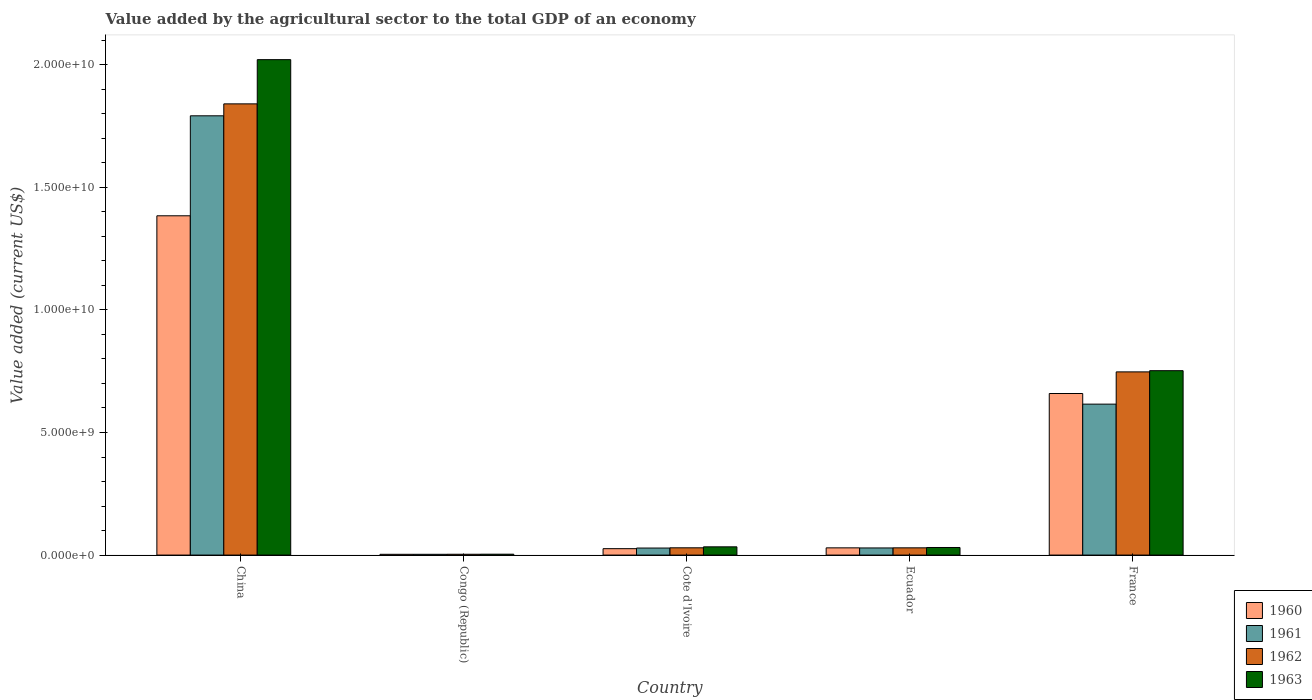How many bars are there on the 2nd tick from the left?
Provide a short and direct response. 4. What is the label of the 1st group of bars from the left?
Keep it short and to the point. China. In how many cases, is the number of bars for a given country not equal to the number of legend labels?
Give a very brief answer. 0. What is the value added by the agricultural sector to the total GDP in 1962 in Congo (Republic)?
Offer a terse response. 3.30e+07. Across all countries, what is the maximum value added by the agricultural sector to the total GDP in 1961?
Keep it short and to the point. 1.79e+1. Across all countries, what is the minimum value added by the agricultural sector to the total GDP in 1962?
Your answer should be compact. 3.30e+07. In which country was the value added by the agricultural sector to the total GDP in 1961 minimum?
Make the answer very short. Congo (Republic). What is the total value added by the agricultural sector to the total GDP in 1960 in the graph?
Offer a very short reply. 2.10e+1. What is the difference between the value added by the agricultural sector to the total GDP in 1960 in Ecuador and that in France?
Provide a succinct answer. -6.30e+09. What is the difference between the value added by the agricultural sector to the total GDP in 1963 in Ecuador and the value added by the agricultural sector to the total GDP in 1962 in France?
Your answer should be compact. -7.16e+09. What is the average value added by the agricultural sector to the total GDP in 1962 per country?
Your response must be concise. 5.30e+09. What is the difference between the value added by the agricultural sector to the total GDP of/in 1960 and value added by the agricultural sector to the total GDP of/in 1961 in France?
Make the answer very short. 4.33e+08. What is the ratio of the value added by the agricultural sector to the total GDP in 1962 in China to that in Cote d'Ivoire?
Make the answer very short. 62.14. Is the difference between the value added by the agricultural sector to the total GDP in 1960 in China and Congo (Republic) greater than the difference between the value added by the agricultural sector to the total GDP in 1961 in China and Congo (Republic)?
Your answer should be compact. No. What is the difference between the highest and the second highest value added by the agricultural sector to the total GDP in 1962?
Ensure brevity in your answer.  -1.09e+1. What is the difference between the highest and the lowest value added by the agricultural sector to the total GDP in 1962?
Your response must be concise. 1.84e+1. In how many countries, is the value added by the agricultural sector to the total GDP in 1961 greater than the average value added by the agricultural sector to the total GDP in 1961 taken over all countries?
Provide a succinct answer. 2. Is it the case that in every country, the sum of the value added by the agricultural sector to the total GDP in 1960 and value added by the agricultural sector to the total GDP in 1963 is greater than the sum of value added by the agricultural sector to the total GDP in 1961 and value added by the agricultural sector to the total GDP in 1962?
Keep it short and to the point. No. Is it the case that in every country, the sum of the value added by the agricultural sector to the total GDP in 1962 and value added by the agricultural sector to the total GDP in 1963 is greater than the value added by the agricultural sector to the total GDP in 1961?
Keep it short and to the point. Yes. How many countries are there in the graph?
Your answer should be compact. 5. Are the values on the major ticks of Y-axis written in scientific E-notation?
Make the answer very short. Yes. Does the graph contain any zero values?
Your answer should be compact. No. How many legend labels are there?
Your response must be concise. 4. How are the legend labels stacked?
Your answer should be compact. Vertical. What is the title of the graph?
Ensure brevity in your answer.  Value added by the agricultural sector to the total GDP of an economy. What is the label or title of the Y-axis?
Offer a very short reply. Value added (current US$). What is the Value added (current US$) of 1960 in China?
Make the answer very short. 1.38e+1. What is the Value added (current US$) in 1961 in China?
Give a very brief answer. 1.79e+1. What is the Value added (current US$) in 1962 in China?
Offer a terse response. 1.84e+1. What is the Value added (current US$) of 1963 in China?
Offer a very short reply. 2.02e+1. What is the Value added (current US$) of 1960 in Congo (Republic)?
Your answer should be compact. 3.11e+07. What is the Value added (current US$) of 1961 in Congo (Republic)?
Your response must be concise. 3.11e+07. What is the Value added (current US$) of 1962 in Congo (Republic)?
Provide a short and direct response. 3.30e+07. What is the Value added (current US$) of 1963 in Congo (Republic)?
Your response must be concise. 3.61e+07. What is the Value added (current US$) of 1960 in Cote d'Ivoire?
Give a very brief answer. 2.62e+08. What is the Value added (current US$) in 1961 in Cote d'Ivoire?
Keep it short and to the point. 2.87e+08. What is the Value added (current US$) in 1962 in Cote d'Ivoire?
Your response must be concise. 2.96e+08. What is the Value added (current US$) in 1963 in Cote d'Ivoire?
Provide a short and direct response. 3.36e+08. What is the Value added (current US$) in 1960 in Ecuador?
Your response must be concise. 2.94e+08. What is the Value added (current US$) of 1961 in Ecuador?
Offer a terse response. 2.91e+08. What is the Value added (current US$) in 1962 in Ecuador?
Give a very brief answer. 2.95e+08. What is the Value added (current US$) of 1963 in Ecuador?
Your answer should be very brief. 3.09e+08. What is the Value added (current US$) of 1960 in France?
Make the answer very short. 6.59e+09. What is the Value added (current US$) of 1961 in France?
Your answer should be very brief. 6.16e+09. What is the Value added (current US$) of 1962 in France?
Provide a succinct answer. 7.47e+09. What is the Value added (current US$) in 1963 in France?
Provide a succinct answer. 7.52e+09. Across all countries, what is the maximum Value added (current US$) in 1960?
Make the answer very short. 1.38e+1. Across all countries, what is the maximum Value added (current US$) of 1961?
Your answer should be very brief. 1.79e+1. Across all countries, what is the maximum Value added (current US$) in 1962?
Provide a short and direct response. 1.84e+1. Across all countries, what is the maximum Value added (current US$) of 1963?
Make the answer very short. 2.02e+1. Across all countries, what is the minimum Value added (current US$) in 1960?
Offer a very short reply. 3.11e+07. Across all countries, what is the minimum Value added (current US$) of 1961?
Ensure brevity in your answer.  3.11e+07. Across all countries, what is the minimum Value added (current US$) in 1962?
Offer a terse response. 3.30e+07. Across all countries, what is the minimum Value added (current US$) in 1963?
Make the answer very short. 3.61e+07. What is the total Value added (current US$) in 1960 in the graph?
Keep it short and to the point. 2.10e+1. What is the total Value added (current US$) of 1961 in the graph?
Keep it short and to the point. 2.47e+1. What is the total Value added (current US$) in 1962 in the graph?
Your answer should be compact. 2.65e+1. What is the total Value added (current US$) in 1963 in the graph?
Your answer should be compact. 2.84e+1. What is the difference between the Value added (current US$) in 1960 in China and that in Congo (Republic)?
Provide a succinct answer. 1.38e+1. What is the difference between the Value added (current US$) of 1961 in China and that in Congo (Republic)?
Provide a succinct answer. 1.79e+1. What is the difference between the Value added (current US$) of 1962 in China and that in Congo (Republic)?
Offer a terse response. 1.84e+1. What is the difference between the Value added (current US$) in 1963 in China and that in Congo (Republic)?
Your response must be concise. 2.02e+1. What is the difference between the Value added (current US$) in 1960 in China and that in Cote d'Ivoire?
Offer a terse response. 1.36e+1. What is the difference between the Value added (current US$) in 1961 in China and that in Cote d'Ivoire?
Give a very brief answer. 1.76e+1. What is the difference between the Value added (current US$) of 1962 in China and that in Cote d'Ivoire?
Your response must be concise. 1.81e+1. What is the difference between the Value added (current US$) in 1963 in China and that in Cote d'Ivoire?
Your response must be concise. 1.99e+1. What is the difference between the Value added (current US$) in 1960 in China and that in Ecuador?
Offer a very short reply. 1.35e+1. What is the difference between the Value added (current US$) of 1961 in China and that in Ecuador?
Offer a very short reply. 1.76e+1. What is the difference between the Value added (current US$) of 1962 in China and that in Ecuador?
Your answer should be very brief. 1.81e+1. What is the difference between the Value added (current US$) of 1963 in China and that in Ecuador?
Your response must be concise. 1.99e+1. What is the difference between the Value added (current US$) in 1960 in China and that in France?
Offer a very short reply. 7.25e+09. What is the difference between the Value added (current US$) of 1961 in China and that in France?
Offer a very short reply. 1.18e+1. What is the difference between the Value added (current US$) of 1962 in China and that in France?
Your answer should be compact. 1.09e+1. What is the difference between the Value added (current US$) in 1963 in China and that in France?
Provide a short and direct response. 1.27e+1. What is the difference between the Value added (current US$) of 1960 in Congo (Republic) and that in Cote d'Ivoire?
Your answer should be very brief. -2.31e+08. What is the difference between the Value added (current US$) of 1961 in Congo (Republic) and that in Cote d'Ivoire?
Give a very brief answer. -2.56e+08. What is the difference between the Value added (current US$) of 1962 in Congo (Republic) and that in Cote d'Ivoire?
Make the answer very short. -2.63e+08. What is the difference between the Value added (current US$) of 1963 in Congo (Republic) and that in Cote d'Ivoire?
Provide a succinct answer. -3.00e+08. What is the difference between the Value added (current US$) in 1960 in Congo (Republic) and that in Ecuador?
Give a very brief answer. -2.63e+08. What is the difference between the Value added (current US$) in 1961 in Congo (Republic) and that in Ecuador?
Offer a very short reply. -2.59e+08. What is the difference between the Value added (current US$) in 1962 in Congo (Republic) and that in Ecuador?
Give a very brief answer. -2.62e+08. What is the difference between the Value added (current US$) of 1963 in Congo (Republic) and that in Ecuador?
Your answer should be very brief. -2.73e+08. What is the difference between the Value added (current US$) of 1960 in Congo (Republic) and that in France?
Ensure brevity in your answer.  -6.56e+09. What is the difference between the Value added (current US$) in 1961 in Congo (Republic) and that in France?
Give a very brief answer. -6.13e+09. What is the difference between the Value added (current US$) of 1962 in Congo (Republic) and that in France?
Your response must be concise. -7.44e+09. What is the difference between the Value added (current US$) of 1963 in Congo (Republic) and that in France?
Your answer should be compact. -7.49e+09. What is the difference between the Value added (current US$) in 1960 in Cote d'Ivoire and that in Ecuador?
Offer a terse response. -3.28e+07. What is the difference between the Value added (current US$) in 1961 in Cote d'Ivoire and that in Ecuador?
Make the answer very short. -3.61e+06. What is the difference between the Value added (current US$) of 1962 in Cote d'Ivoire and that in Ecuador?
Offer a very short reply. 1.03e+06. What is the difference between the Value added (current US$) of 1963 in Cote d'Ivoire and that in Ecuador?
Provide a succinct answer. 2.70e+07. What is the difference between the Value added (current US$) in 1960 in Cote d'Ivoire and that in France?
Provide a short and direct response. -6.33e+09. What is the difference between the Value added (current US$) of 1961 in Cote d'Ivoire and that in France?
Offer a terse response. -5.87e+09. What is the difference between the Value added (current US$) in 1962 in Cote d'Ivoire and that in France?
Offer a very short reply. -7.18e+09. What is the difference between the Value added (current US$) in 1963 in Cote d'Ivoire and that in France?
Your answer should be compact. -7.19e+09. What is the difference between the Value added (current US$) of 1960 in Ecuador and that in France?
Offer a very short reply. -6.30e+09. What is the difference between the Value added (current US$) of 1961 in Ecuador and that in France?
Your answer should be compact. -5.87e+09. What is the difference between the Value added (current US$) in 1962 in Ecuador and that in France?
Keep it short and to the point. -7.18e+09. What is the difference between the Value added (current US$) in 1963 in Ecuador and that in France?
Make the answer very short. -7.21e+09. What is the difference between the Value added (current US$) in 1960 in China and the Value added (current US$) in 1961 in Congo (Republic)?
Keep it short and to the point. 1.38e+1. What is the difference between the Value added (current US$) in 1960 in China and the Value added (current US$) in 1962 in Congo (Republic)?
Provide a short and direct response. 1.38e+1. What is the difference between the Value added (current US$) in 1960 in China and the Value added (current US$) in 1963 in Congo (Republic)?
Make the answer very short. 1.38e+1. What is the difference between the Value added (current US$) of 1961 in China and the Value added (current US$) of 1962 in Congo (Republic)?
Give a very brief answer. 1.79e+1. What is the difference between the Value added (current US$) of 1961 in China and the Value added (current US$) of 1963 in Congo (Republic)?
Your answer should be compact. 1.79e+1. What is the difference between the Value added (current US$) in 1962 in China and the Value added (current US$) in 1963 in Congo (Republic)?
Provide a short and direct response. 1.84e+1. What is the difference between the Value added (current US$) in 1960 in China and the Value added (current US$) in 1961 in Cote d'Ivoire?
Keep it short and to the point. 1.36e+1. What is the difference between the Value added (current US$) of 1960 in China and the Value added (current US$) of 1962 in Cote d'Ivoire?
Make the answer very short. 1.35e+1. What is the difference between the Value added (current US$) of 1960 in China and the Value added (current US$) of 1963 in Cote d'Ivoire?
Provide a succinct answer. 1.35e+1. What is the difference between the Value added (current US$) in 1961 in China and the Value added (current US$) in 1962 in Cote d'Ivoire?
Ensure brevity in your answer.  1.76e+1. What is the difference between the Value added (current US$) of 1961 in China and the Value added (current US$) of 1963 in Cote d'Ivoire?
Offer a very short reply. 1.76e+1. What is the difference between the Value added (current US$) in 1962 in China and the Value added (current US$) in 1963 in Cote d'Ivoire?
Provide a short and direct response. 1.81e+1. What is the difference between the Value added (current US$) of 1960 in China and the Value added (current US$) of 1961 in Ecuador?
Keep it short and to the point. 1.35e+1. What is the difference between the Value added (current US$) of 1960 in China and the Value added (current US$) of 1962 in Ecuador?
Your response must be concise. 1.35e+1. What is the difference between the Value added (current US$) of 1960 in China and the Value added (current US$) of 1963 in Ecuador?
Ensure brevity in your answer.  1.35e+1. What is the difference between the Value added (current US$) of 1961 in China and the Value added (current US$) of 1962 in Ecuador?
Provide a succinct answer. 1.76e+1. What is the difference between the Value added (current US$) of 1961 in China and the Value added (current US$) of 1963 in Ecuador?
Your answer should be compact. 1.76e+1. What is the difference between the Value added (current US$) in 1962 in China and the Value added (current US$) in 1963 in Ecuador?
Provide a succinct answer. 1.81e+1. What is the difference between the Value added (current US$) in 1960 in China and the Value added (current US$) in 1961 in France?
Provide a short and direct response. 7.68e+09. What is the difference between the Value added (current US$) of 1960 in China and the Value added (current US$) of 1962 in France?
Keep it short and to the point. 6.37e+09. What is the difference between the Value added (current US$) in 1960 in China and the Value added (current US$) in 1963 in France?
Ensure brevity in your answer.  6.32e+09. What is the difference between the Value added (current US$) of 1961 in China and the Value added (current US$) of 1962 in France?
Offer a very short reply. 1.04e+1. What is the difference between the Value added (current US$) of 1961 in China and the Value added (current US$) of 1963 in France?
Offer a terse response. 1.04e+1. What is the difference between the Value added (current US$) of 1962 in China and the Value added (current US$) of 1963 in France?
Your response must be concise. 1.09e+1. What is the difference between the Value added (current US$) of 1960 in Congo (Republic) and the Value added (current US$) of 1961 in Cote d'Ivoire?
Give a very brief answer. -2.56e+08. What is the difference between the Value added (current US$) of 1960 in Congo (Republic) and the Value added (current US$) of 1962 in Cote d'Ivoire?
Make the answer very short. -2.65e+08. What is the difference between the Value added (current US$) in 1960 in Congo (Republic) and the Value added (current US$) in 1963 in Cote d'Ivoire?
Offer a terse response. -3.05e+08. What is the difference between the Value added (current US$) in 1961 in Congo (Republic) and the Value added (current US$) in 1962 in Cote d'Ivoire?
Keep it short and to the point. -2.65e+08. What is the difference between the Value added (current US$) in 1961 in Congo (Republic) and the Value added (current US$) in 1963 in Cote d'Ivoire?
Your answer should be compact. -3.05e+08. What is the difference between the Value added (current US$) of 1962 in Congo (Republic) and the Value added (current US$) of 1963 in Cote d'Ivoire?
Give a very brief answer. -3.03e+08. What is the difference between the Value added (current US$) in 1960 in Congo (Republic) and the Value added (current US$) in 1961 in Ecuador?
Give a very brief answer. -2.59e+08. What is the difference between the Value added (current US$) in 1960 in Congo (Republic) and the Value added (current US$) in 1962 in Ecuador?
Your answer should be compact. -2.64e+08. What is the difference between the Value added (current US$) of 1960 in Congo (Republic) and the Value added (current US$) of 1963 in Ecuador?
Your response must be concise. -2.78e+08. What is the difference between the Value added (current US$) of 1961 in Congo (Republic) and the Value added (current US$) of 1962 in Ecuador?
Your answer should be very brief. -2.64e+08. What is the difference between the Value added (current US$) in 1961 in Congo (Republic) and the Value added (current US$) in 1963 in Ecuador?
Provide a short and direct response. -2.78e+08. What is the difference between the Value added (current US$) in 1962 in Congo (Republic) and the Value added (current US$) in 1963 in Ecuador?
Your response must be concise. -2.76e+08. What is the difference between the Value added (current US$) of 1960 in Congo (Republic) and the Value added (current US$) of 1961 in France?
Offer a terse response. -6.13e+09. What is the difference between the Value added (current US$) of 1960 in Congo (Republic) and the Value added (current US$) of 1962 in France?
Provide a short and direct response. -7.44e+09. What is the difference between the Value added (current US$) of 1960 in Congo (Republic) and the Value added (current US$) of 1963 in France?
Keep it short and to the point. -7.49e+09. What is the difference between the Value added (current US$) of 1961 in Congo (Republic) and the Value added (current US$) of 1962 in France?
Provide a short and direct response. -7.44e+09. What is the difference between the Value added (current US$) of 1961 in Congo (Republic) and the Value added (current US$) of 1963 in France?
Keep it short and to the point. -7.49e+09. What is the difference between the Value added (current US$) in 1962 in Congo (Republic) and the Value added (current US$) in 1963 in France?
Keep it short and to the point. -7.49e+09. What is the difference between the Value added (current US$) of 1960 in Cote d'Ivoire and the Value added (current US$) of 1961 in Ecuador?
Provide a succinct answer. -2.88e+07. What is the difference between the Value added (current US$) of 1960 in Cote d'Ivoire and the Value added (current US$) of 1962 in Ecuador?
Offer a very short reply. -3.35e+07. What is the difference between the Value added (current US$) of 1960 in Cote d'Ivoire and the Value added (current US$) of 1963 in Ecuador?
Offer a terse response. -4.74e+07. What is the difference between the Value added (current US$) of 1961 in Cote d'Ivoire and the Value added (current US$) of 1962 in Ecuador?
Ensure brevity in your answer.  -8.28e+06. What is the difference between the Value added (current US$) of 1961 in Cote d'Ivoire and the Value added (current US$) of 1963 in Ecuador?
Offer a terse response. -2.22e+07. What is the difference between the Value added (current US$) in 1962 in Cote d'Ivoire and the Value added (current US$) in 1963 in Ecuador?
Give a very brief answer. -1.29e+07. What is the difference between the Value added (current US$) of 1960 in Cote d'Ivoire and the Value added (current US$) of 1961 in France?
Give a very brief answer. -5.90e+09. What is the difference between the Value added (current US$) in 1960 in Cote d'Ivoire and the Value added (current US$) in 1962 in France?
Your response must be concise. -7.21e+09. What is the difference between the Value added (current US$) of 1960 in Cote d'Ivoire and the Value added (current US$) of 1963 in France?
Ensure brevity in your answer.  -7.26e+09. What is the difference between the Value added (current US$) in 1961 in Cote d'Ivoire and the Value added (current US$) in 1962 in France?
Provide a short and direct response. -7.19e+09. What is the difference between the Value added (current US$) in 1961 in Cote d'Ivoire and the Value added (current US$) in 1963 in France?
Offer a very short reply. -7.23e+09. What is the difference between the Value added (current US$) of 1962 in Cote d'Ivoire and the Value added (current US$) of 1963 in France?
Ensure brevity in your answer.  -7.23e+09. What is the difference between the Value added (current US$) in 1960 in Ecuador and the Value added (current US$) in 1961 in France?
Provide a succinct answer. -5.86e+09. What is the difference between the Value added (current US$) of 1960 in Ecuador and the Value added (current US$) of 1962 in France?
Offer a very short reply. -7.18e+09. What is the difference between the Value added (current US$) of 1960 in Ecuador and the Value added (current US$) of 1963 in France?
Ensure brevity in your answer.  -7.23e+09. What is the difference between the Value added (current US$) in 1961 in Ecuador and the Value added (current US$) in 1962 in France?
Offer a very short reply. -7.18e+09. What is the difference between the Value added (current US$) in 1961 in Ecuador and the Value added (current US$) in 1963 in France?
Offer a very short reply. -7.23e+09. What is the difference between the Value added (current US$) in 1962 in Ecuador and the Value added (current US$) in 1963 in France?
Provide a succinct answer. -7.23e+09. What is the average Value added (current US$) of 1960 per country?
Your answer should be compact. 4.20e+09. What is the average Value added (current US$) in 1961 per country?
Give a very brief answer. 4.94e+09. What is the average Value added (current US$) of 1962 per country?
Offer a very short reply. 5.30e+09. What is the average Value added (current US$) of 1963 per country?
Offer a very short reply. 5.68e+09. What is the difference between the Value added (current US$) in 1960 and Value added (current US$) in 1961 in China?
Your response must be concise. -4.08e+09. What is the difference between the Value added (current US$) in 1960 and Value added (current US$) in 1962 in China?
Keep it short and to the point. -4.57e+09. What is the difference between the Value added (current US$) of 1960 and Value added (current US$) of 1963 in China?
Your answer should be compact. -6.37e+09. What is the difference between the Value added (current US$) in 1961 and Value added (current US$) in 1962 in China?
Your answer should be very brief. -4.87e+08. What is the difference between the Value added (current US$) in 1961 and Value added (current US$) in 1963 in China?
Offer a terse response. -2.29e+09. What is the difference between the Value added (current US$) in 1962 and Value added (current US$) in 1963 in China?
Make the answer very short. -1.80e+09. What is the difference between the Value added (current US$) in 1960 and Value added (current US$) in 1961 in Congo (Republic)?
Provide a succinct answer. 8239.47. What is the difference between the Value added (current US$) in 1960 and Value added (current US$) in 1962 in Congo (Republic)?
Keep it short and to the point. -1.89e+06. What is the difference between the Value added (current US$) of 1960 and Value added (current US$) of 1963 in Congo (Republic)?
Ensure brevity in your answer.  -5.00e+06. What is the difference between the Value added (current US$) in 1961 and Value added (current US$) in 1962 in Congo (Republic)?
Make the answer very short. -1.90e+06. What is the difference between the Value added (current US$) in 1961 and Value added (current US$) in 1963 in Congo (Republic)?
Keep it short and to the point. -5.01e+06. What is the difference between the Value added (current US$) of 1962 and Value added (current US$) of 1963 in Congo (Republic)?
Offer a very short reply. -3.11e+06. What is the difference between the Value added (current US$) in 1960 and Value added (current US$) in 1961 in Cote d'Ivoire?
Ensure brevity in your answer.  -2.52e+07. What is the difference between the Value added (current US$) of 1960 and Value added (current US$) of 1962 in Cote d'Ivoire?
Provide a short and direct response. -3.45e+07. What is the difference between the Value added (current US$) of 1960 and Value added (current US$) of 1963 in Cote d'Ivoire?
Offer a terse response. -7.45e+07. What is the difference between the Value added (current US$) in 1961 and Value added (current US$) in 1962 in Cote d'Ivoire?
Your response must be concise. -9.30e+06. What is the difference between the Value added (current US$) in 1961 and Value added (current US$) in 1963 in Cote d'Ivoire?
Your answer should be compact. -4.92e+07. What is the difference between the Value added (current US$) of 1962 and Value added (current US$) of 1963 in Cote d'Ivoire?
Your response must be concise. -3.99e+07. What is the difference between the Value added (current US$) of 1960 and Value added (current US$) of 1961 in Ecuador?
Your answer should be very brief. 3.96e+06. What is the difference between the Value added (current US$) in 1960 and Value added (current US$) in 1962 in Ecuador?
Provide a succinct answer. -6.97e+05. What is the difference between the Value added (current US$) in 1960 and Value added (current US$) in 1963 in Ecuador?
Your answer should be very brief. -1.46e+07. What is the difference between the Value added (current US$) of 1961 and Value added (current US$) of 1962 in Ecuador?
Give a very brief answer. -4.66e+06. What is the difference between the Value added (current US$) of 1961 and Value added (current US$) of 1963 in Ecuador?
Keep it short and to the point. -1.86e+07. What is the difference between the Value added (current US$) in 1962 and Value added (current US$) in 1963 in Ecuador?
Provide a succinct answer. -1.39e+07. What is the difference between the Value added (current US$) in 1960 and Value added (current US$) in 1961 in France?
Your answer should be compact. 4.33e+08. What is the difference between the Value added (current US$) in 1960 and Value added (current US$) in 1962 in France?
Offer a very short reply. -8.82e+08. What is the difference between the Value added (current US$) in 1960 and Value added (current US$) in 1963 in France?
Your answer should be compact. -9.31e+08. What is the difference between the Value added (current US$) of 1961 and Value added (current US$) of 1962 in France?
Ensure brevity in your answer.  -1.32e+09. What is the difference between the Value added (current US$) of 1961 and Value added (current US$) of 1963 in France?
Offer a very short reply. -1.36e+09. What is the difference between the Value added (current US$) of 1962 and Value added (current US$) of 1963 in France?
Offer a very short reply. -4.92e+07. What is the ratio of the Value added (current US$) in 1960 in China to that in Congo (Republic)?
Offer a terse response. 445.15. What is the ratio of the Value added (current US$) of 1961 in China to that in Congo (Republic)?
Ensure brevity in your answer.  576.48. What is the ratio of the Value added (current US$) of 1962 in China to that in Congo (Republic)?
Your response must be concise. 558.09. What is the ratio of the Value added (current US$) of 1963 in China to that in Congo (Republic)?
Give a very brief answer. 559.95. What is the ratio of the Value added (current US$) in 1960 in China to that in Cote d'Ivoire?
Your answer should be compact. 52.89. What is the ratio of the Value added (current US$) in 1961 in China to that in Cote d'Ivoire?
Keep it short and to the point. 62.45. What is the ratio of the Value added (current US$) of 1962 in China to that in Cote d'Ivoire?
Offer a terse response. 62.14. What is the ratio of the Value added (current US$) of 1963 in China to that in Cote d'Ivoire?
Provide a succinct answer. 60.12. What is the ratio of the Value added (current US$) in 1960 in China to that in Ecuador?
Offer a terse response. 47. What is the ratio of the Value added (current US$) of 1961 in China to that in Ecuador?
Ensure brevity in your answer.  61.67. What is the ratio of the Value added (current US$) in 1962 in China to that in Ecuador?
Give a very brief answer. 62.35. What is the ratio of the Value added (current US$) of 1963 in China to that in Ecuador?
Provide a short and direct response. 65.37. What is the ratio of the Value added (current US$) of 1961 in China to that in France?
Your answer should be compact. 2.91. What is the ratio of the Value added (current US$) in 1962 in China to that in France?
Ensure brevity in your answer.  2.46. What is the ratio of the Value added (current US$) of 1963 in China to that in France?
Your answer should be very brief. 2.69. What is the ratio of the Value added (current US$) in 1960 in Congo (Republic) to that in Cote d'Ivoire?
Your answer should be compact. 0.12. What is the ratio of the Value added (current US$) of 1961 in Congo (Republic) to that in Cote d'Ivoire?
Ensure brevity in your answer.  0.11. What is the ratio of the Value added (current US$) in 1962 in Congo (Republic) to that in Cote d'Ivoire?
Ensure brevity in your answer.  0.11. What is the ratio of the Value added (current US$) in 1963 in Congo (Republic) to that in Cote d'Ivoire?
Your answer should be very brief. 0.11. What is the ratio of the Value added (current US$) in 1960 in Congo (Republic) to that in Ecuador?
Give a very brief answer. 0.11. What is the ratio of the Value added (current US$) in 1961 in Congo (Republic) to that in Ecuador?
Make the answer very short. 0.11. What is the ratio of the Value added (current US$) in 1962 in Congo (Republic) to that in Ecuador?
Offer a terse response. 0.11. What is the ratio of the Value added (current US$) in 1963 in Congo (Republic) to that in Ecuador?
Give a very brief answer. 0.12. What is the ratio of the Value added (current US$) of 1960 in Congo (Republic) to that in France?
Keep it short and to the point. 0. What is the ratio of the Value added (current US$) in 1961 in Congo (Republic) to that in France?
Give a very brief answer. 0.01. What is the ratio of the Value added (current US$) of 1962 in Congo (Republic) to that in France?
Your response must be concise. 0. What is the ratio of the Value added (current US$) of 1963 in Congo (Republic) to that in France?
Your answer should be very brief. 0. What is the ratio of the Value added (current US$) in 1960 in Cote d'Ivoire to that in Ecuador?
Provide a succinct answer. 0.89. What is the ratio of the Value added (current US$) in 1961 in Cote d'Ivoire to that in Ecuador?
Provide a short and direct response. 0.99. What is the ratio of the Value added (current US$) of 1962 in Cote d'Ivoire to that in Ecuador?
Provide a short and direct response. 1. What is the ratio of the Value added (current US$) in 1963 in Cote d'Ivoire to that in Ecuador?
Provide a short and direct response. 1.09. What is the ratio of the Value added (current US$) in 1960 in Cote d'Ivoire to that in France?
Provide a short and direct response. 0.04. What is the ratio of the Value added (current US$) of 1961 in Cote d'Ivoire to that in France?
Provide a short and direct response. 0.05. What is the ratio of the Value added (current US$) in 1962 in Cote d'Ivoire to that in France?
Give a very brief answer. 0.04. What is the ratio of the Value added (current US$) of 1963 in Cote d'Ivoire to that in France?
Offer a very short reply. 0.04. What is the ratio of the Value added (current US$) of 1960 in Ecuador to that in France?
Offer a terse response. 0.04. What is the ratio of the Value added (current US$) of 1961 in Ecuador to that in France?
Your response must be concise. 0.05. What is the ratio of the Value added (current US$) of 1962 in Ecuador to that in France?
Offer a very short reply. 0.04. What is the ratio of the Value added (current US$) in 1963 in Ecuador to that in France?
Provide a short and direct response. 0.04. What is the difference between the highest and the second highest Value added (current US$) in 1960?
Provide a succinct answer. 7.25e+09. What is the difference between the highest and the second highest Value added (current US$) in 1961?
Keep it short and to the point. 1.18e+1. What is the difference between the highest and the second highest Value added (current US$) of 1962?
Provide a succinct answer. 1.09e+1. What is the difference between the highest and the second highest Value added (current US$) in 1963?
Make the answer very short. 1.27e+1. What is the difference between the highest and the lowest Value added (current US$) in 1960?
Provide a succinct answer. 1.38e+1. What is the difference between the highest and the lowest Value added (current US$) of 1961?
Offer a very short reply. 1.79e+1. What is the difference between the highest and the lowest Value added (current US$) of 1962?
Provide a short and direct response. 1.84e+1. What is the difference between the highest and the lowest Value added (current US$) in 1963?
Offer a terse response. 2.02e+1. 